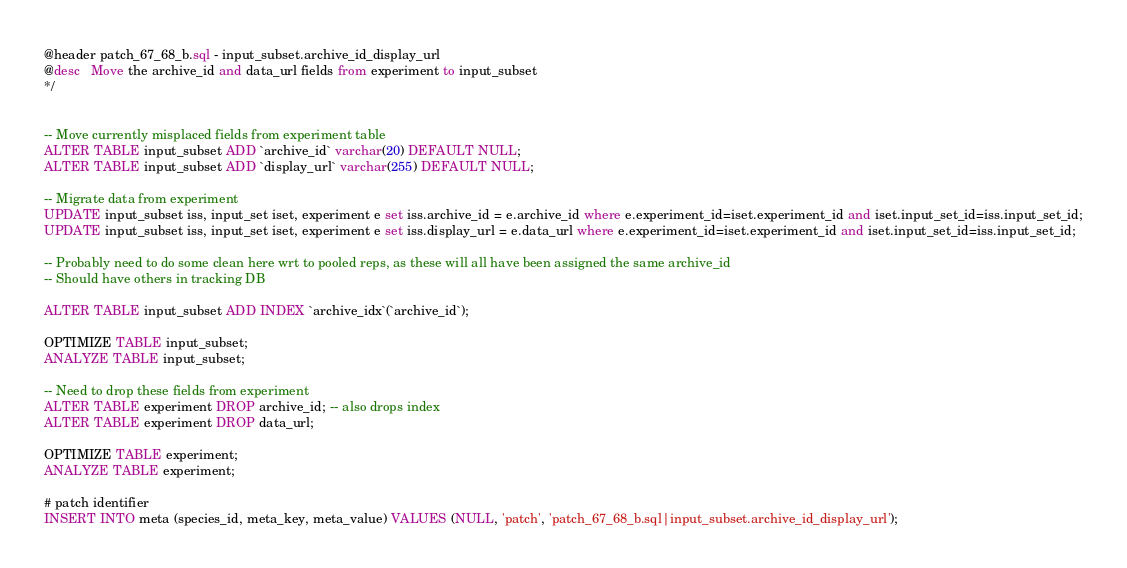<code> <loc_0><loc_0><loc_500><loc_500><_SQL_>@header patch_67_68_b.sql - input_subset.archive_id_display_url
@desc   Move the archive_id and data_url fields from experiment to input_subset
*/


-- Move currently misplaced fields from experiment table
ALTER TABLE input_subset ADD `archive_id` varchar(20) DEFAULT NULL;
ALTER TABLE input_subset ADD `display_url` varchar(255) DEFAULT NULL;

-- Migrate data from experiment
UPDATE input_subset iss, input_set iset, experiment e set iss.archive_id = e.archive_id where e.experiment_id=iset.experiment_id and iset.input_set_id=iss.input_set_id;
UPDATE input_subset iss, input_set iset, experiment e set iss.display_url = e.data_url where e.experiment_id=iset.experiment_id and iset.input_set_id=iss.input_set_id;

-- Probably need to do some clean here wrt to pooled reps, as these will all have been assigned the same archive_id
-- Should have others in tracking DB

ALTER TABLE input_subset ADD INDEX `archive_idx`(`archive_id`);

OPTIMIZE TABLE input_subset;
ANALYZE TABLE input_subset;

-- Need to drop these fields from experiment
ALTER TABLE experiment DROP archive_id; -- also drops index
ALTER TABLE experiment DROP data_url;

OPTIMIZE TABLE experiment;
ANALYZE TABLE experiment;

# patch identifier
INSERT INTO meta (species_id, meta_key, meta_value) VALUES (NULL, 'patch', 'patch_67_68_b.sql|input_subset.archive_id_display_url');


</code> 